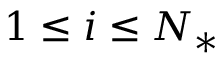<formula> <loc_0><loc_0><loc_500><loc_500>1 \leq i \leq N _ { * }</formula> 